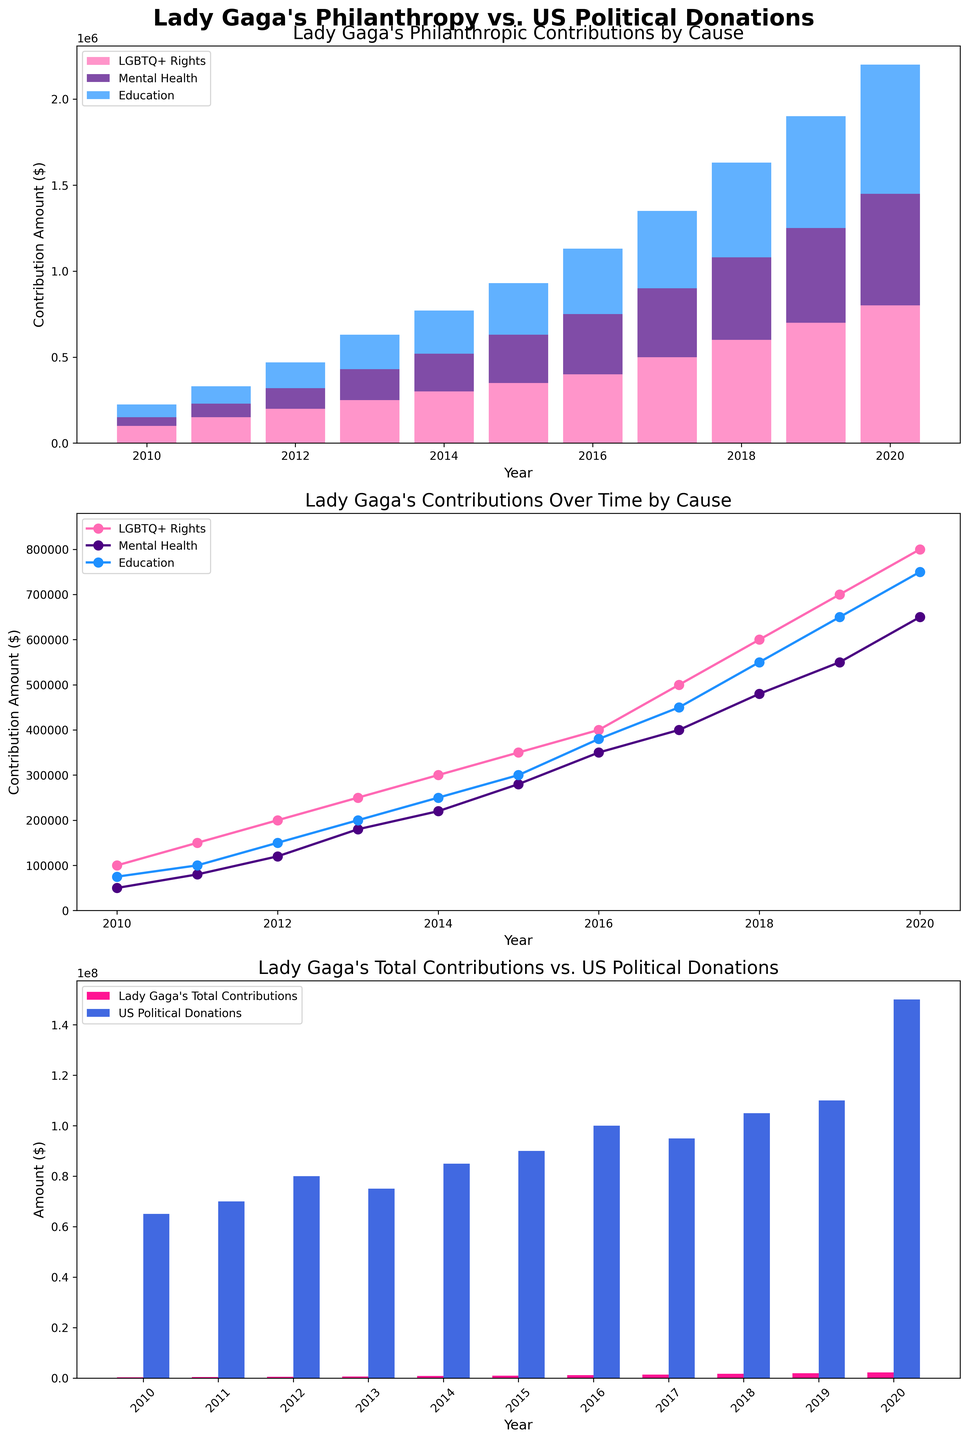How do Lady Gaga's contributions to LGBTQ+ Rights in 2018 compare to her contributions to Education in the same year? In 2018, Lady Gaga's contributions to LGBTQ+ Rights are represented by a higher bar on both the stacked bar chart (first subplot) and line plot (second subplot) compared to her contributions to Education. Specifically looking at the bar's height, LGBTQ+ Rights contributions are around 600,000 while Education contributions are around 550,000.
Answer: LGBTQ+ Rights contributions are higher What is the trend in Lady Gaga's contributions to Mental Health from 2016 to 2018? Looking at the second subplot (line plot), the line representing Mental Health increases from 350,000 in 2016 to 480,000 in 2018. The line's direction is upward, indicating an increasing trend over these years.
Answer: Increasing How do the total contributions Lady Gaga made in 2020 compare to US political donations in the same year? In the third subplot (comparison bar chart), the total contributions made by Lady Gaga in 2020 are represented by the pink bar, which is shorter than the blue bar representing US political donations. Specifically, Lady Gaga's total contributions are around 2,200,000 while US political donations are around 150,000,000.
Answer: Less By how much did Lady Gaga's contributions to Education increase from 2010 to 2020? From the line plot (second subplot), Lady Gaga's contributions to Education in 2010 were about 75,000, and in 2020, they increased to 750,000. The increase is 750,000 - 75,000 = 675,000.
Answer: 675,000 Which cause received the highest total contributions from Lady Gaga over the years? In the first subplot (stacked bar chart) and the second subplot (line plot), the pink bars/line representing LGBTQ+ Rights consistently show higher contribution values across the years compared to other causes. Summing the contributions visually, LGBTQ+ Rights have the highest cumulative total.
Answer: LGBTQ+ Rights What is the difference between Lady Gaga's contributions to Mental Health and US political donations in 2019? In the third subplot (comparison bar chart), Lady Gaga's contributions to Mental Health in 2019, visualized in the second subplot, are about 550,000, while US political donations for that year are around 45,000,000. The difference is 45,000,000 - 550,000 = 44,450,000.
Answer: 44,450,000 Which year saw the largest contribution from Lady Gaga to LGBTQ+ Rights? Evaluating the first subplot (stacked bar chart) and the second subplot (line plot), the year 2020 has the tallest pink bar/highest point on the pink line representing LGBTQ+ Rights contributions at 800,000.
Answer: 2020 Does Lady Gaga's total contributions in 2015 surpass US political donations in the same year? In the third subplot (comparison bar chart), Lady Gaga's total contributions in 2015 are represented by the pink bar, which is significantly lower than the blue bar representing US political donations. Thus, her contributions do not surpass US political donations.
Answer: No 